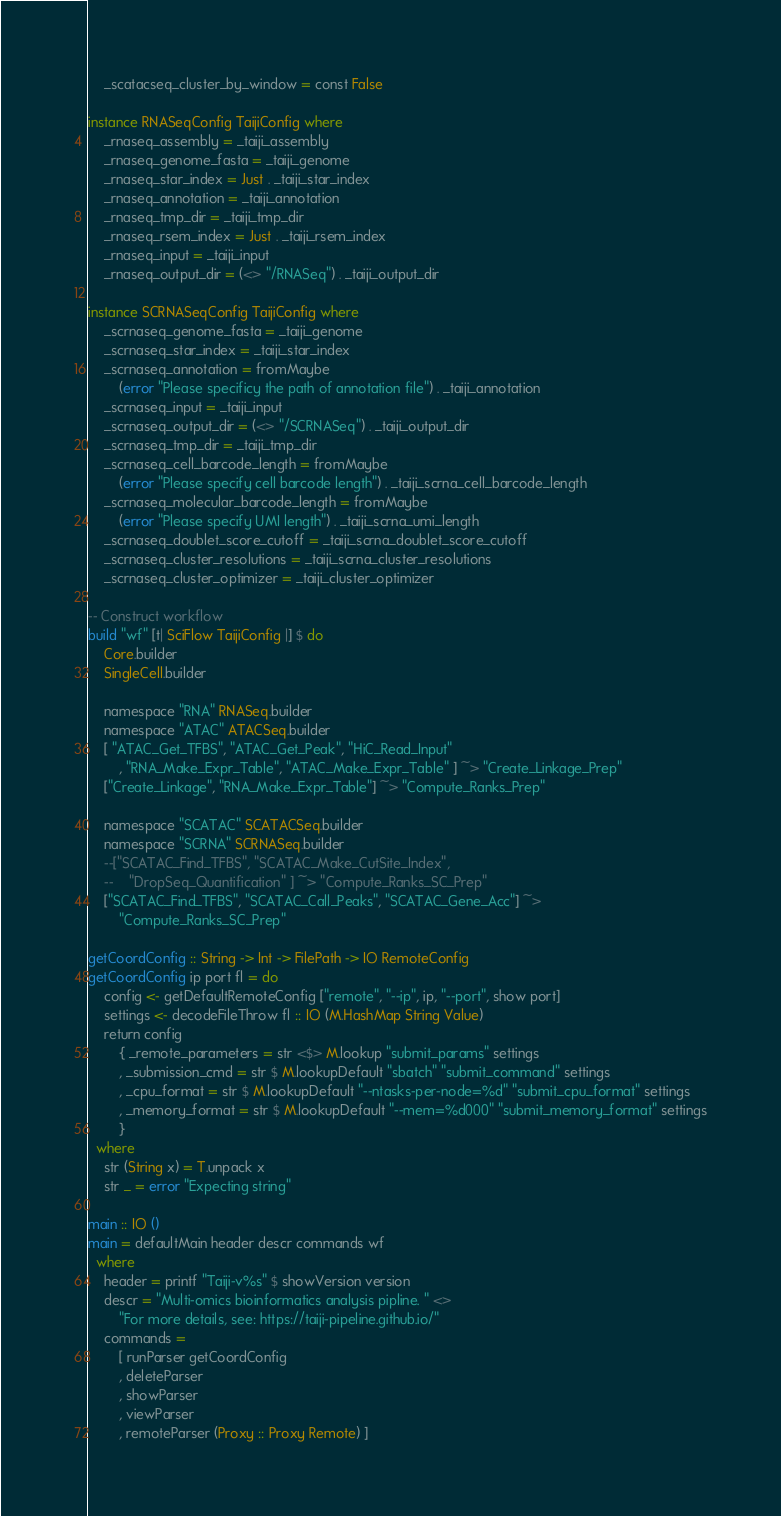Convert code to text. <code><loc_0><loc_0><loc_500><loc_500><_Haskell_>    _scatacseq_cluster_by_window = const False

instance RNASeqConfig TaijiConfig where
    _rnaseq_assembly = _taiji_assembly
    _rnaseq_genome_fasta = _taiji_genome
    _rnaseq_star_index = Just . _taiji_star_index
    _rnaseq_annotation = _taiji_annotation
    _rnaseq_tmp_dir = _taiji_tmp_dir
    _rnaseq_rsem_index = Just . _taiji_rsem_index
    _rnaseq_input = _taiji_input
    _rnaseq_output_dir = (<> "/RNASeq") . _taiji_output_dir

instance SCRNASeqConfig TaijiConfig where
    _scrnaseq_genome_fasta = _taiji_genome
    _scrnaseq_star_index = _taiji_star_index
    _scrnaseq_annotation = fromMaybe
        (error "Please specificy the path of annotation file") . _taiji_annotation
    _scrnaseq_input = _taiji_input
    _scrnaseq_output_dir = (<> "/SCRNASeq") . _taiji_output_dir
    _scrnaseq_tmp_dir = _taiji_tmp_dir
    _scrnaseq_cell_barcode_length = fromMaybe
        (error "Please specify cell barcode length") . _taiji_scrna_cell_barcode_length 
    _scrnaseq_molecular_barcode_length = fromMaybe
        (error "Please specify UMI length") . _taiji_scrna_umi_length
    _scrnaseq_doublet_score_cutoff = _taiji_scrna_doublet_score_cutoff 
    _scrnaseq_cluster_resolutions = _taiji_scrna_cluster_resolutions
    _scrnaseq_cluster_optimizer = _taiji_cluster_optimizer

-- Construct workflow
build "wf" [t| SciFlow TaijiConfig |] $ do
    Core.builder
    SingleCell.builder

    namespace "RNA" RNASeq.builder
    namespace "ATAC" ATACSeq.builder
    [ "ATAC_Get_TFBS", "ATAC_Get_Peak", "HiC_Read_Input"
        , "RNA_Make_Expr_Table", "ATAC_Make_Expr_Table" ] ~> "Create_Linkage_Prep"
    ["Create_Linkage", "RNA_Make_Expr_Table"] ~> "Compute_Ranks_Prep"

    namespace "SCATAC" SCATACSeq.builder
    namespace "SCRNA" SCRNASeq.builder
    --["SCATAC_Find_TFBS", "SCATAC_Make_CutSite_Index",
    --    "DropSeq_Quantification" ] ~> "Compute_Ranks_SC_Prep"
    ["SCATAC_Find_TFBS", "SCATAC_Call_Peaks", "SCATAC_Gene_Acc"] ~>
        "Compute_Ranks_SC_Prep"

getCoordConfig :: String -> Int -> FilePath -> IO RemoteConfig
getCoordConfig ip port fl = do
    config <- getDefaultRemoteConfig ["remote", "--ip", ip, "--port", show port]
    settings <- decodeFileThrow fl :: IO (M.HashMap String Value)
    return config
        { _remote_parameters = str <$> M.lookup "submit_params" settings
        , _submission_cmd = str $ M.lookupDefault "sbatch" "submit_command" settings
        , _cpu_format = str $ M.lookupDefault "--ntasks-per-node=%d" "submit_cpu_format" settings
        , _memory_format = str $ M.lookupDefault "--mem=%d000" "submit_memory_format" settings
        }
  where
    str (String x) = T.unpack x
    str _ = error "Expecting string"

main :: IO ()
main = defaultMain header descr commands wf
  where
    header = printf "Taiji-v%s" $ showVersion version
    descr = "Multi-omics bioinformatics analysis pipline. " <>
        "For more details, see: https://taiji-pipeline.github.io/"
    commands =
        [ runParser getCoordConfig
        , deleteParser
        , showParser
        , viewParser
        , remoteParser (Proxy :: Proxy Remote) ]
</code> 